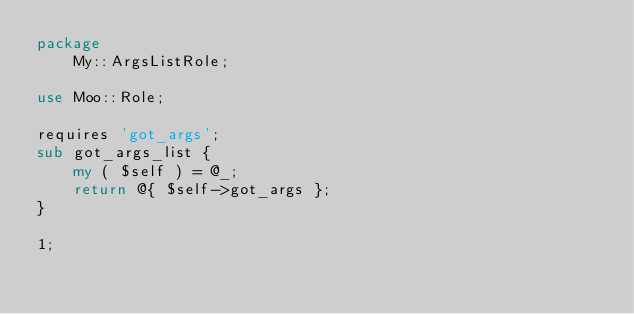<code> <loc_0><loc_0><loc_500><loc_500><_Perl_>package
    My::ArgsListRole;

use Moo::Role;

requires 'got_args';
sub got_args_list {
    my ( $self ) = @_;
    return @{ $self->got_args };
}

1;
</code> 